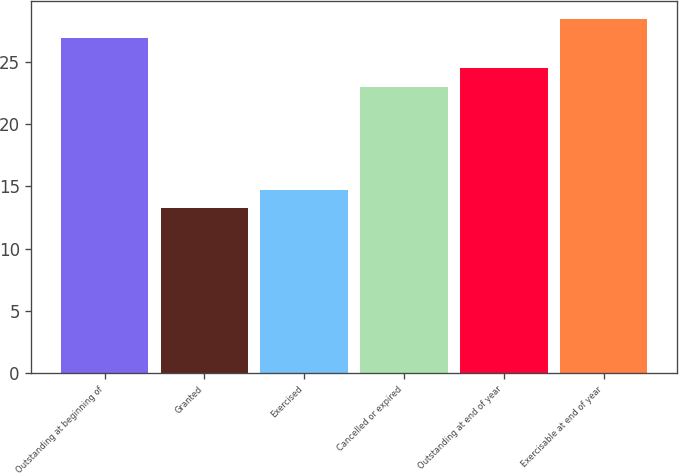<chart> <loc_0><loc_0><loc_500><loc_500><bar_chart><fcel>Outstanding at beginning of<fcel>Granted<fcel>Exercised<fcel>Cancelled or expired<fcel>Outstanding at end of year<fcel>Exercisable at end of year<nl><fcel>26.96<fcel>13.23<fcel>14.74<fcel>23.02<fcel>24.53<fcel>28.47<nl></chart> 